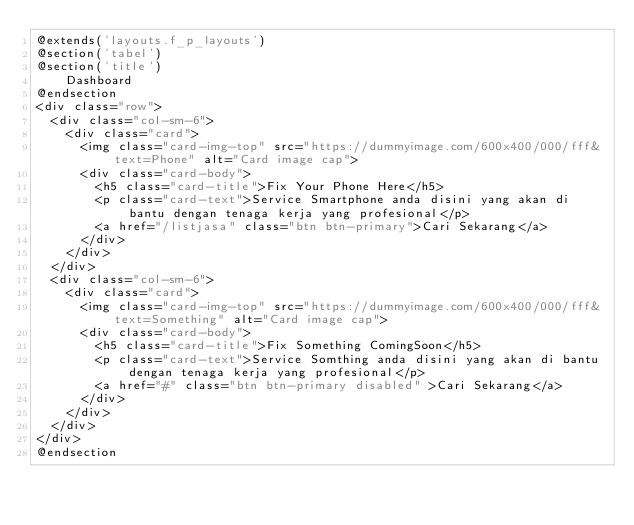<code> <loc_0><loc_0><loc_500><loc_500><_PHP_>@extends('layouts.f_p_layouts')
@section('tabel')
@section('title')
    Dashboard
@endsection
<div class="row">
  <div class="col-sm-6">
    <div class="card">
      <img class="card-img-top" src="https://dummyimage.com/600x400/000/fff&text=Phone" alt="Card image cap">
      <div class="card-body">
        <h5 class="card-title">Fix Your Phone Here</h5>
        <p class="card-text">Service Smartphone anda disini yang akan di bantu dengan tenaga kerja yang profesional</p>
        <a href="/listjasa" class="btn btn-primary">Cari Sekarang</a>
      </div>
    </div>
  </div>
  <div class="col-sm-6">
    <div class="card">
      <img class="card-img-top" src="https://dummyimage.com/600x400/000/fff&text=Something" alt="Card image cap">
      <div class="card-body">
        <h5 class="card-title">Fix Something ComingSoon</h5>
        <p class="card-text">Service Somthing anda disini yang akan di bantu dengan tenaga kerja yang profesional</p>
        <a href="#" class="btn btn-primary disabled" >Cari Sekarang</a>
      </div>
    </div>
  </div>
</div>             
@endsection</code> 